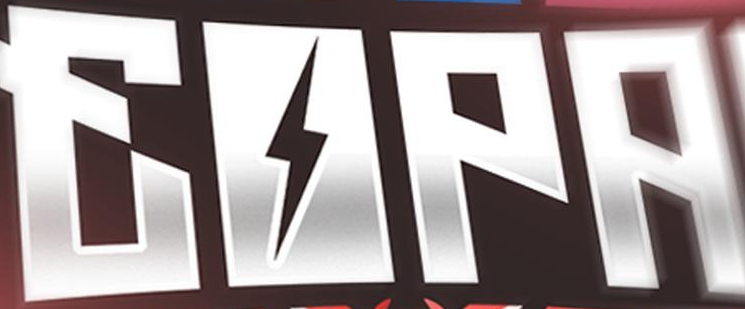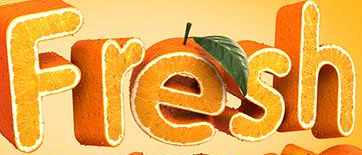What words can you see in these images in sequence, separated by a semicolon? EOPA; Fresh 